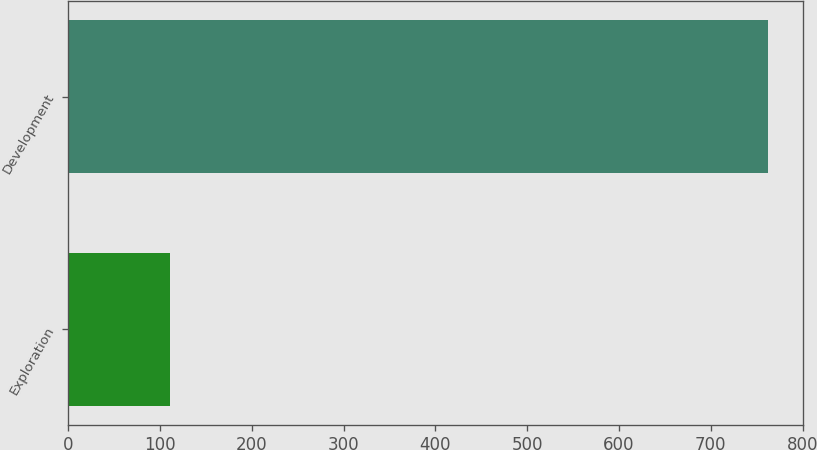Convert chart to OTSL. <chart><loc_0><loc_0><loc_500><loc_500><bar_chart><fcel>Exploration<fcel>Development<nl><fcel>111<fcel>762<nl></chart> 